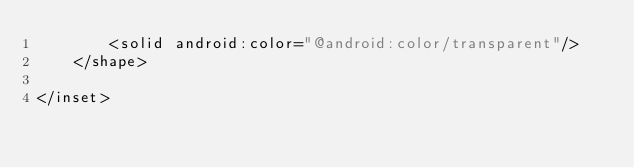<code> <loc_0><loc_0><loc_500><loc_500><_XML_>        <solid android:color="@android:color/transparent"/>
    </shape>

</inset></code> 